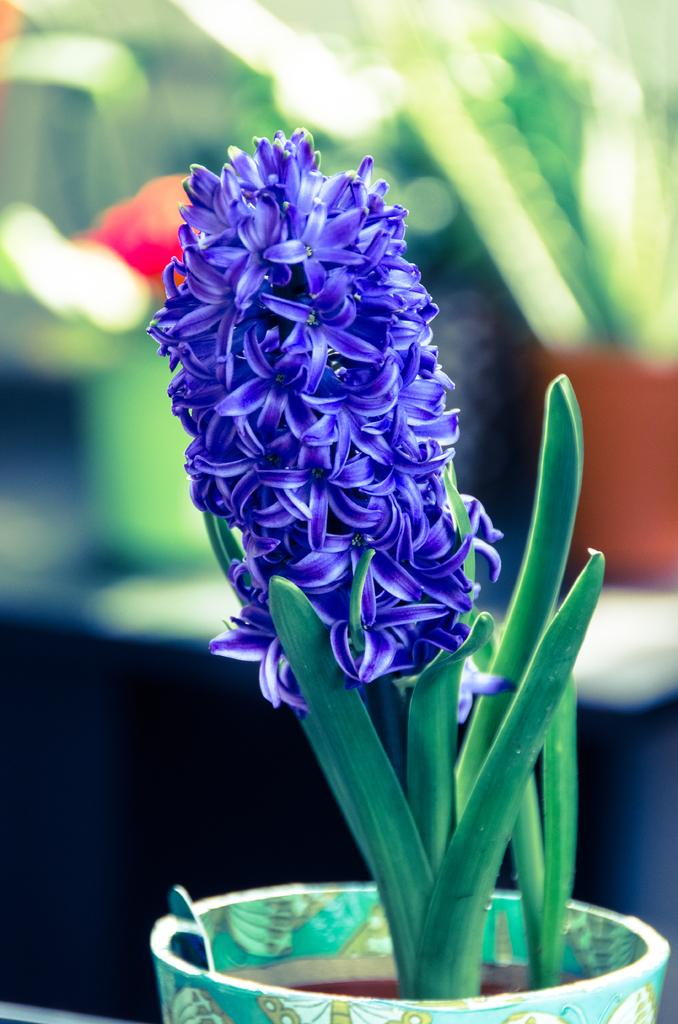What is the focus of the image? The image is zoomed in, so the focus is on a specific area. What can be seen in the foreground of the image? There are flowers and a plant in a pot in the foreground of the image. How would you describe the background of the image? The background of the image is blurry and green in color. What type of locket is hanging from the plant in the image? There is no locket hanging from the plant in the image. How comfortable is the cushion in the background of the image? There is no cushion present in the image; it only features flowers, a plant in a pot, and a green background. 